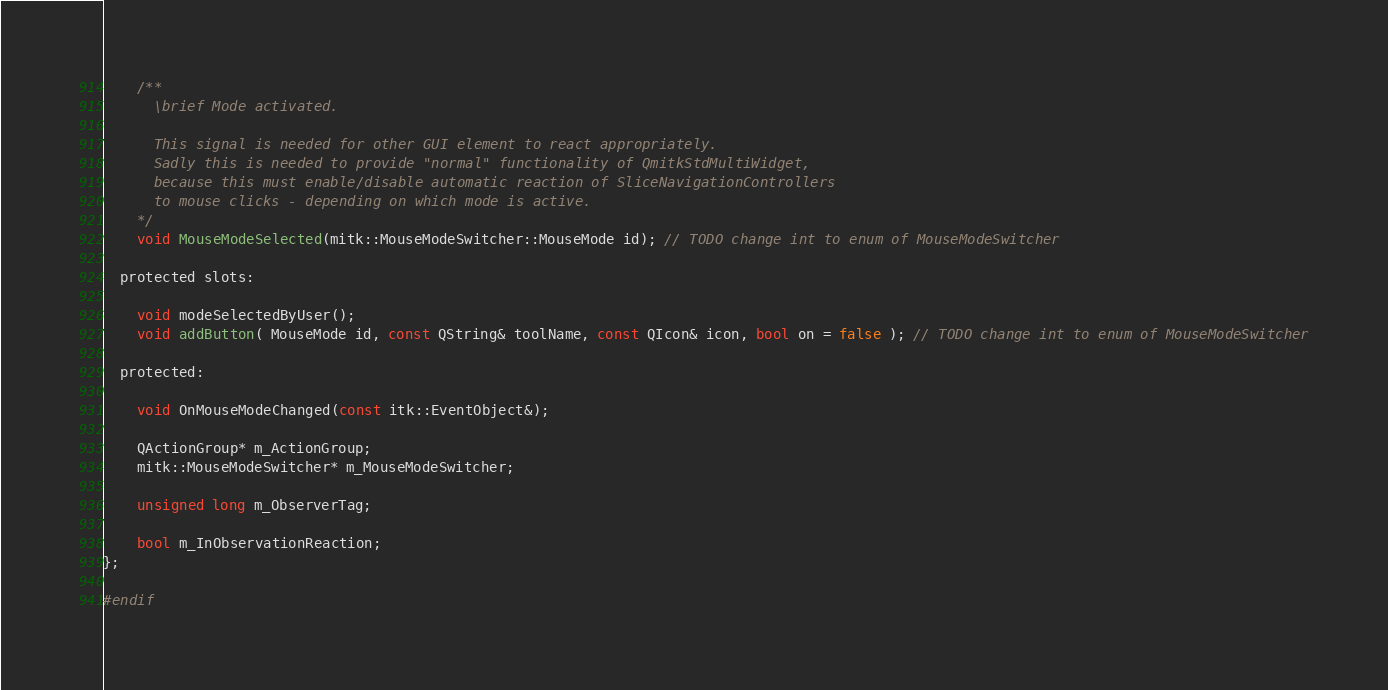<code> <loc_0><loc_0><loc_500><loc_500><_C_>
    /**
      \brief Mode activated.

      This signal is needed for other GUI element to react appropriately.
      Sadly this is needed to provide "normal" functionality of QmitkStdMultiWidget,
      because this must enable/disable automatic reaction of SliceNavigationControllers
      to mouse clicks - depending on which mode is active.
    */
    void MouseModeSelected(mitk::MouseModeSwitcher::MouseMode id); // TODO change int to enum of MouseModeSwitcher

  protected slots:

    void modeSelectedByUser();
    void addButton( MouseMode id, const QString& toolName, const QIcon& icon, bool on = false ); // TODO change int to enum of MouseModeSwitcher

  protected:

    void OnMouseModeChanged(const itk::EventObject&);

    QActionGroup* m_ActionGroup;
    mitk::MouseModeSwitcher* m_MouseModeSwitcher;

    unsigned long m_ObserverTag;

    bool m_InObservationReaction;
};

#endif

</code> 